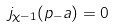Convert formula to latex. <formula><loc_0><loc_0><loc_500><loc_500>j _ { \chi - 1 } ( p _ { - } a ) = 0</formula> 